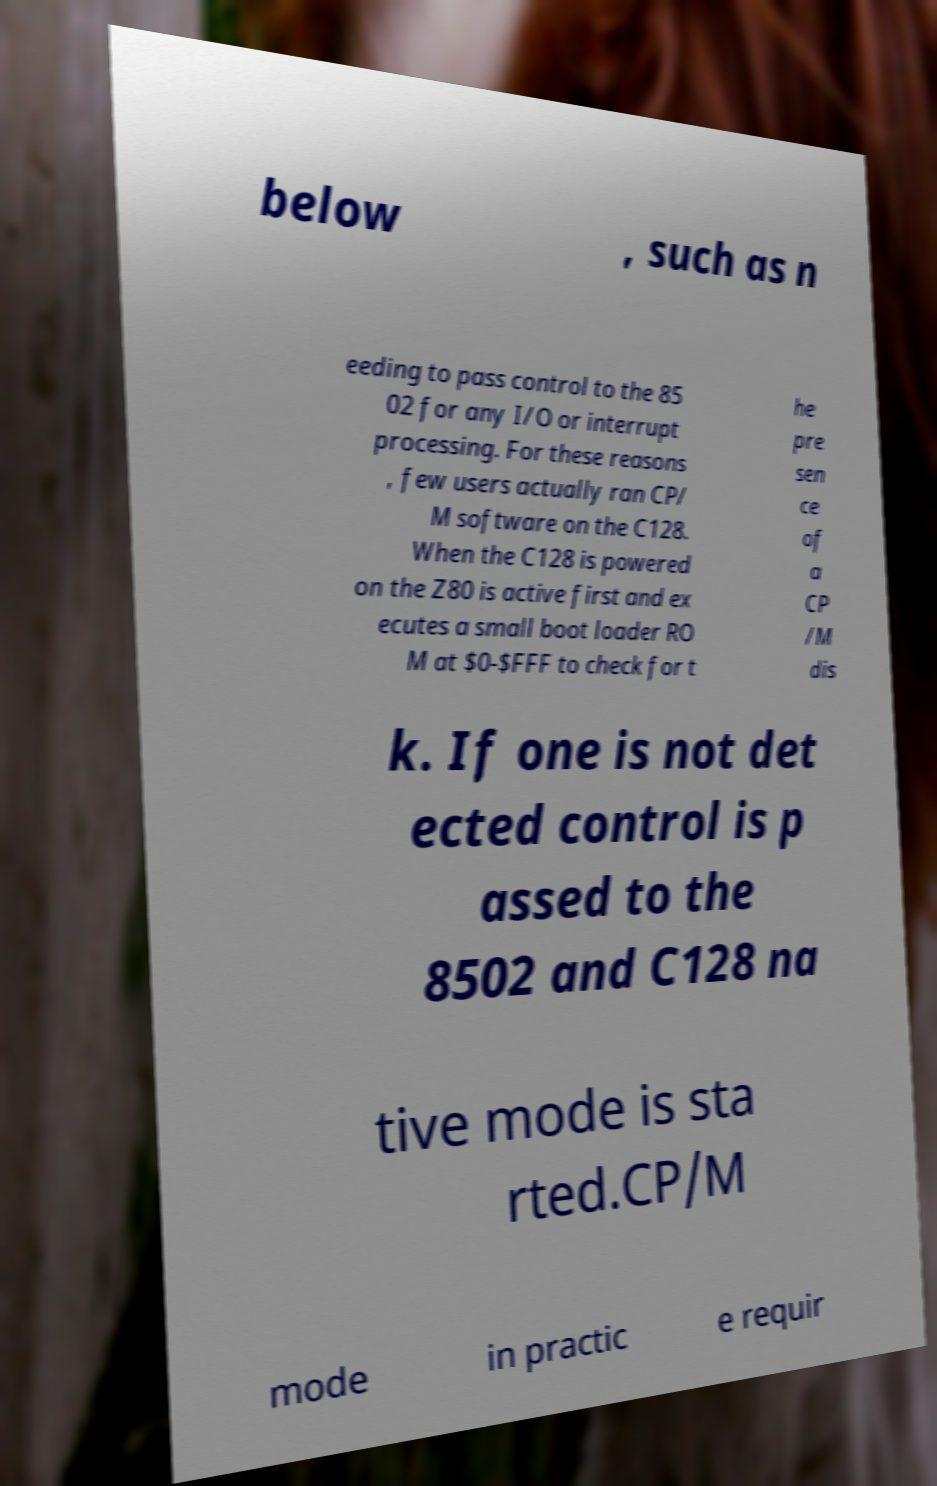I need the written content from this picture converted into text. Can you do that? below , such as n eeding to pass control to the 85 02 for any I/O or interrupt processing. For these reasons , few users actually ran CP/ M software on the C128. When the C128 is powered on the Z80 is active first and ex ecutes a small boot loader RO M at $0-$FFF to check for t he pre sen ce of a CP /M dis k. If one is not det ected control is p assed to the 8502 and C128 na tive mode is sta rted.CP/M mode in practic e requir 